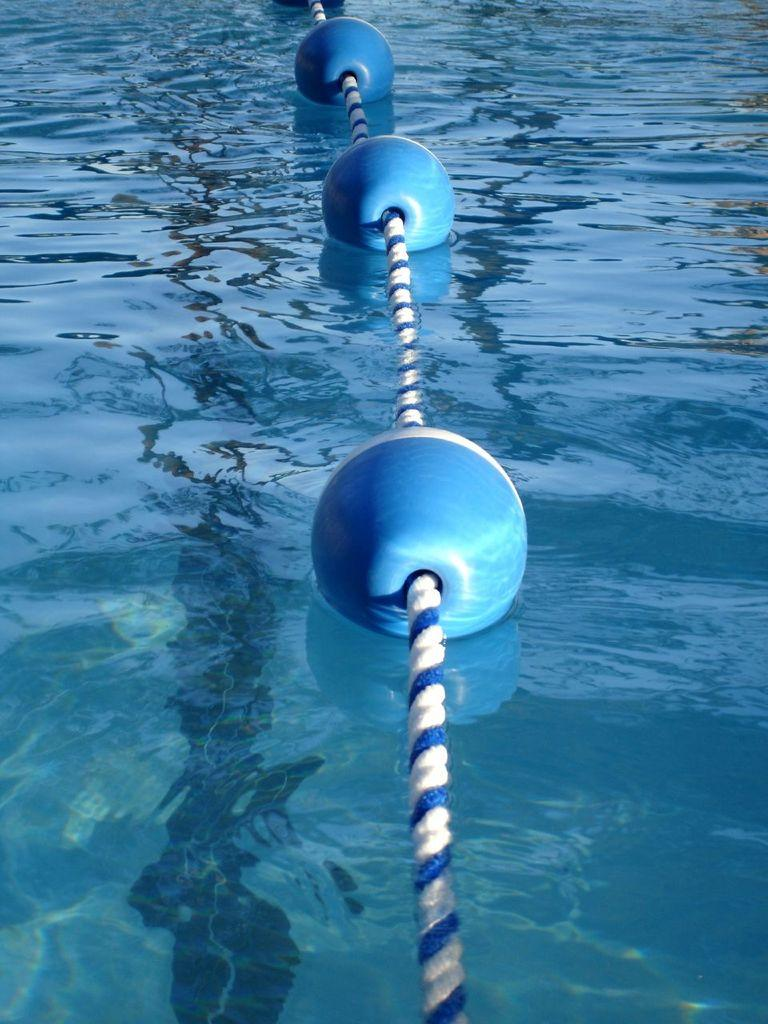What objects are floating in the image? There are floating balls in the image. How are the floating balls connected to each other? The floating balls are attached with a rope. Where are the floating balls and rope located? They are on water. Can you tell me how many legs are visible on the floating balls in the image? The floating balls in the image do not have legs, as they are inanimate objects. 